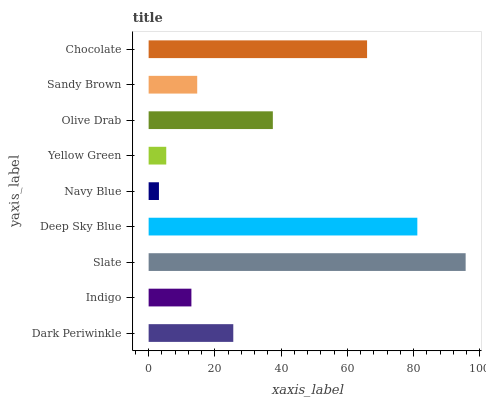Is Navy Blue the minimum?
Answer yes or no. Yes. Is Slate the maximum?
Answer yes or no. Yes. Is Indigo the minimum?
Answer yes or no. No. Is Indigo the maximum?
Answer yes or no. No. Is Dark Periwinkle greater than Indigo?
Answer yes or no. Yes. Is Indigo less than Dark Periwinkle?
Answer yes or no. Yes. Is Indigo greater than Dark Periwinkle?
Answer yes or no. No. Is Dark Periwinkle less than Indigo?
Answer yes or no. No. Is Dark Periwinkle the high median?
Answer yes or no. Yes. Is Dark Periwinkle the low median?
Answer yes or no. Yes. Is Yellow Green the high median?
Answer yes or no. No. Is Slate the low median?
Answer yes or no. No. 